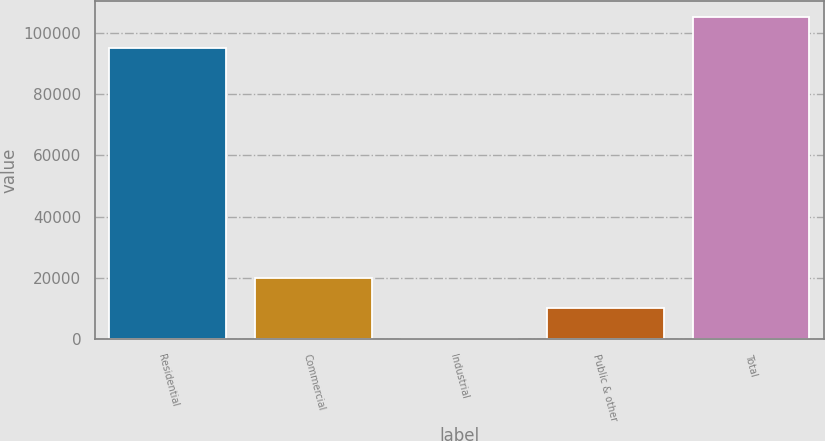Convert chart to OTSL. <chart><loc_0><loc_0><loc_500><loc_500><bar_chart><fcel>Residential<fcel>Commercial<fcel>Industrial<fcel>Public & other<fcel>Total<nl><fcel>95092<fcel>20165.6<fcel>13<fcel>10089.3<fcel>105168<nl></chart> 